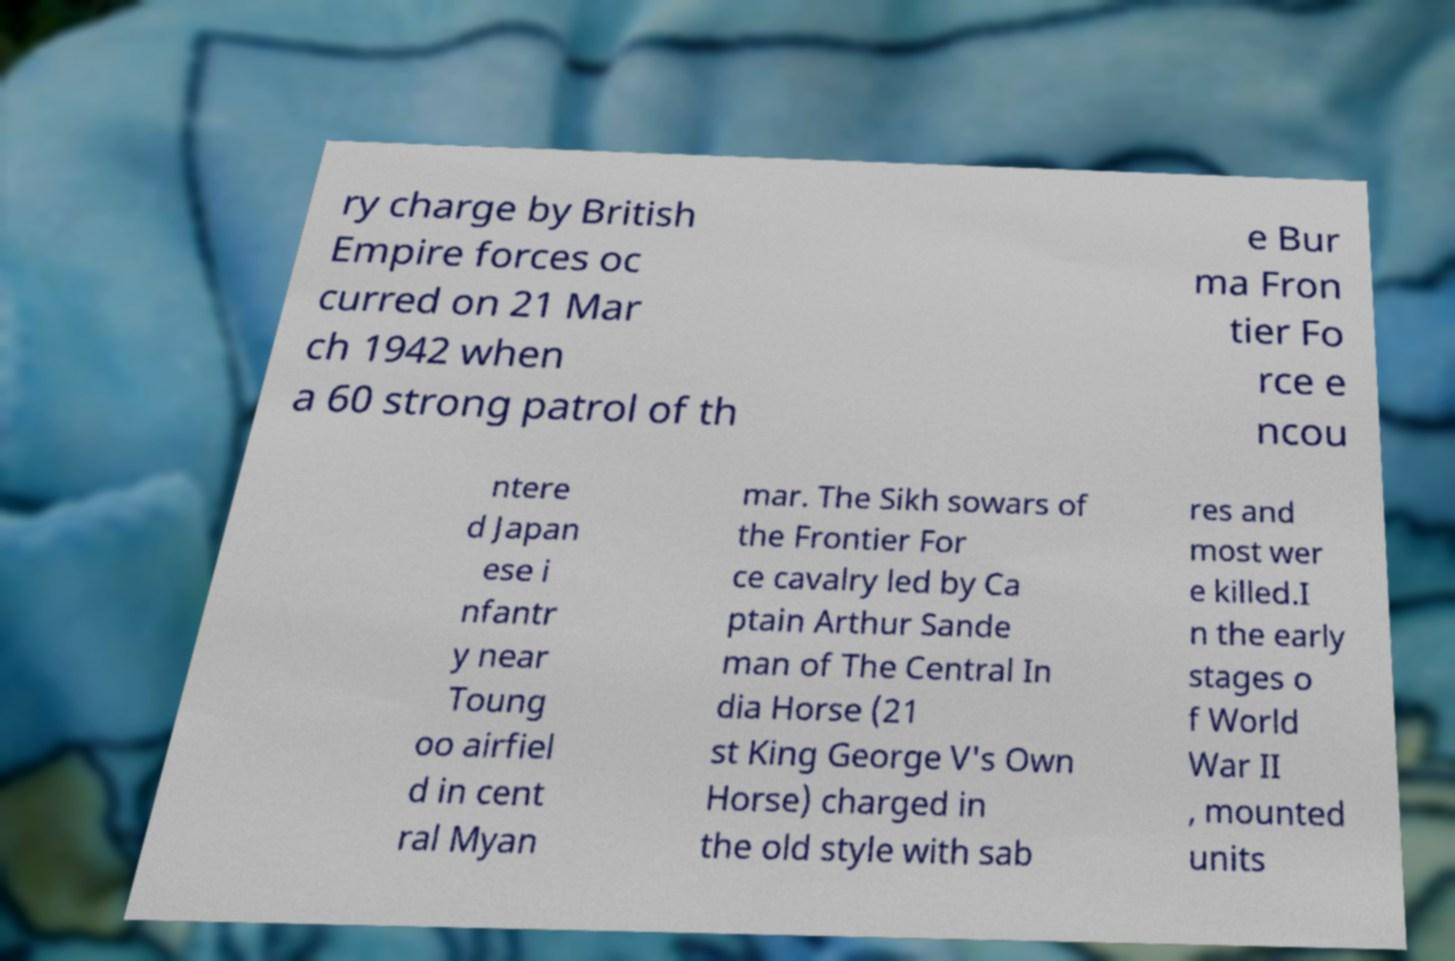There's text embedded in this image that I need extracted. Can you transcribe it verbatim? ry charge by British Empire forces oc curred on 21 Mar ch 1942 when a 60 strong patrol of th e Bur ma Fron tier Fo rce e ncou ntere d Japan ese i nfantr y near Toung oo airfiel d in cent ral Myan mar. The Sikh sowars of the Frontier For ce cavalry led by Ca ptain Arthur Sande man of The Central In dia Horse (21 st King George V's Own Horse) charged in the old style with sab res and most wer e killed.I n the early stages o f World War II , mounted units 